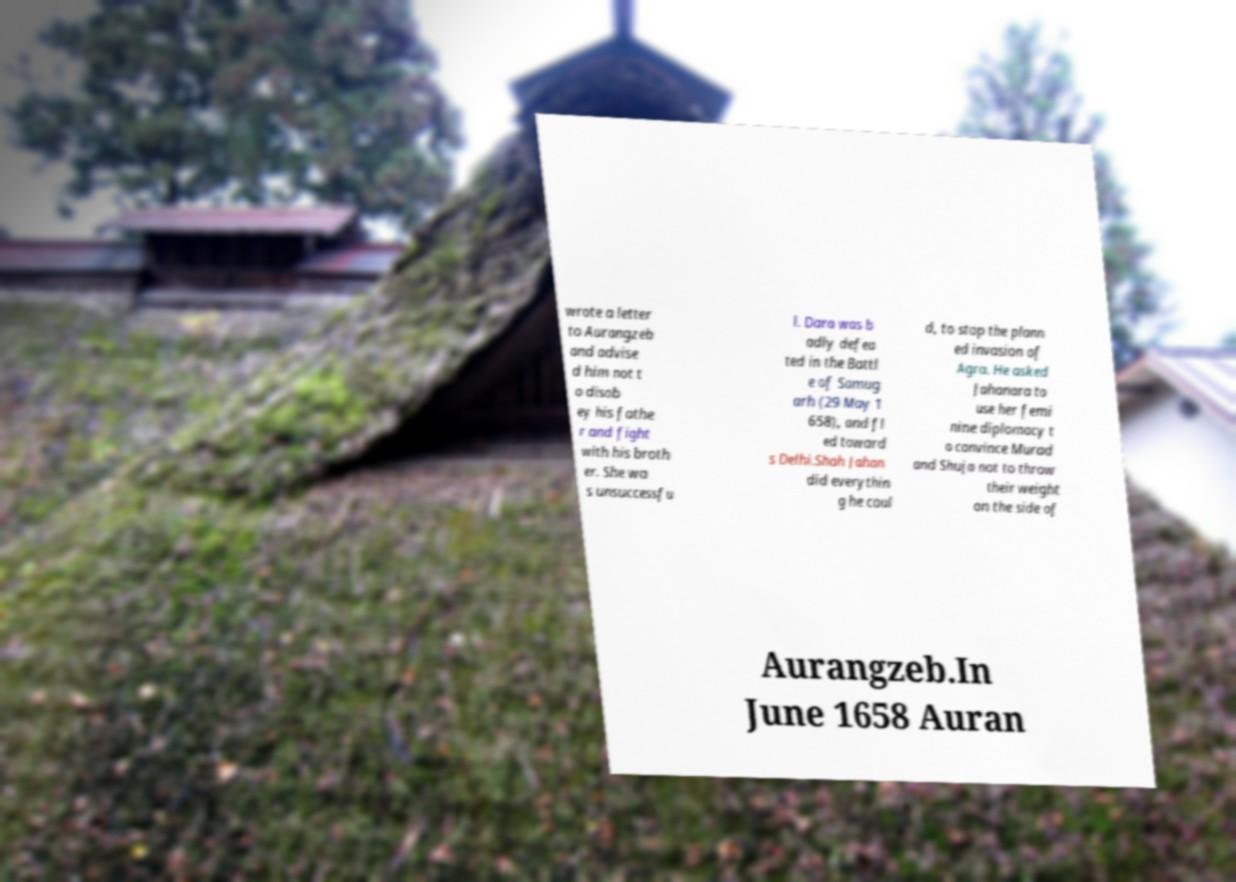Could you extract and type out the text from this image? wrote a letter to Aurangzeb and advise d him not t o disob ey his fathe r and fight with his broth er. She wa s unsuccessfu l. Dara was b adly defea ted in the Battl e of Samug arh (29 May 1 658), and fl ed toward s Delhi.Shah Jahan did everythin g he coul d, to stop the plann ed invasion of Agra. He asked Jahanara to use her femi nine diplomacy t o convince Murad and Shuja not to throw their weight on the side of Aurangzeb.In June 1658 Auran 